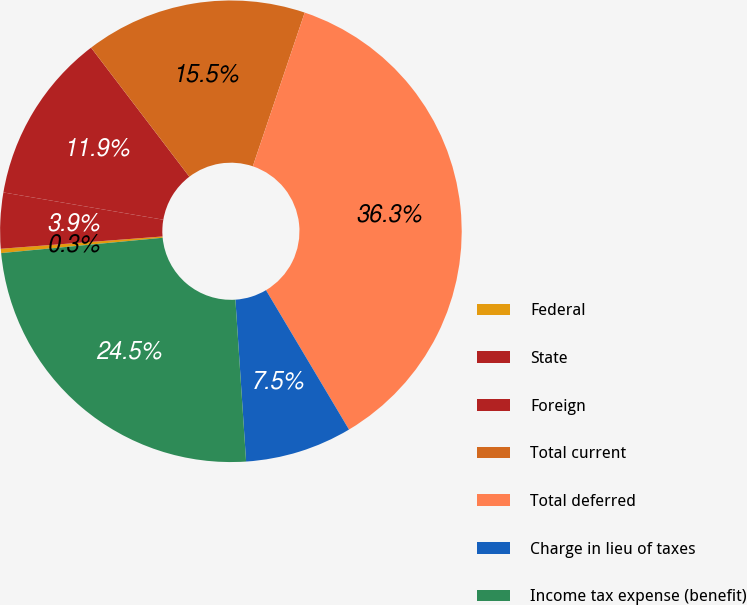Convert chart. <chart><loc_0><loc_0><loc_500><loc_500><pie_chart><fcel>Federal<fcel>State<fcel>Foreign<fcel>Total current<fcel>Total deferred<fcel>Charge in lieu of taxes<fcel>Income tax expense (benefit)<nl><fcel>0.3%<fcel>3.9%<fcel>11.95%<fcel>15.54%<fcel>36.27%<fcel>7.5%<fcel>24.54%<nl></chart> 